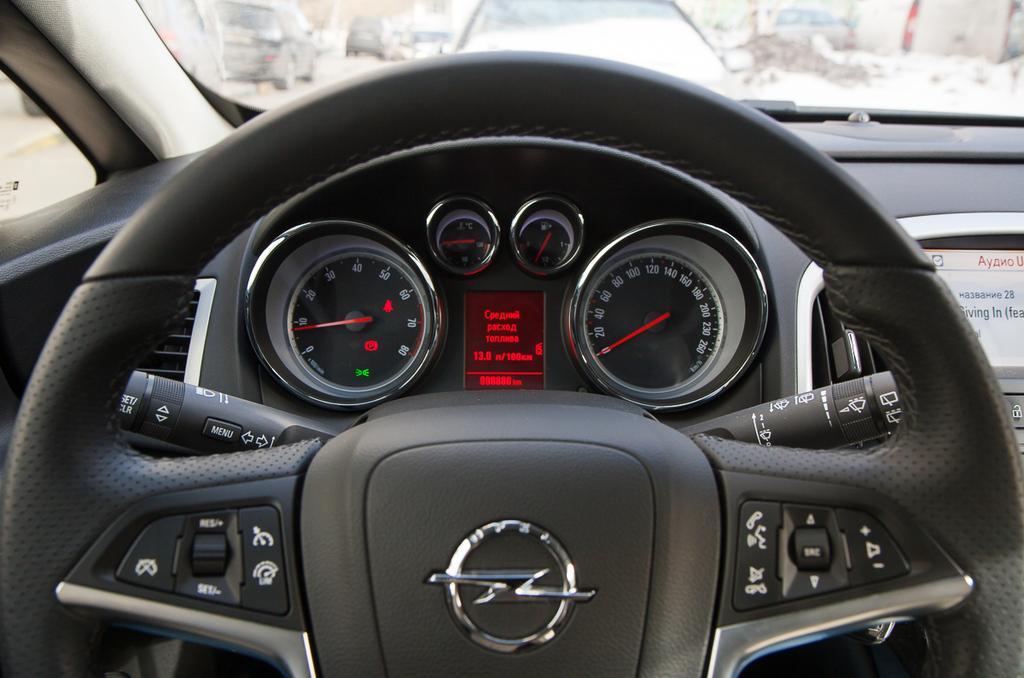Could you give a brief overview of what you see in this image? Here there are cars, this is steering and ac events, this is speedometer, this is digital screen, these are buttons. 